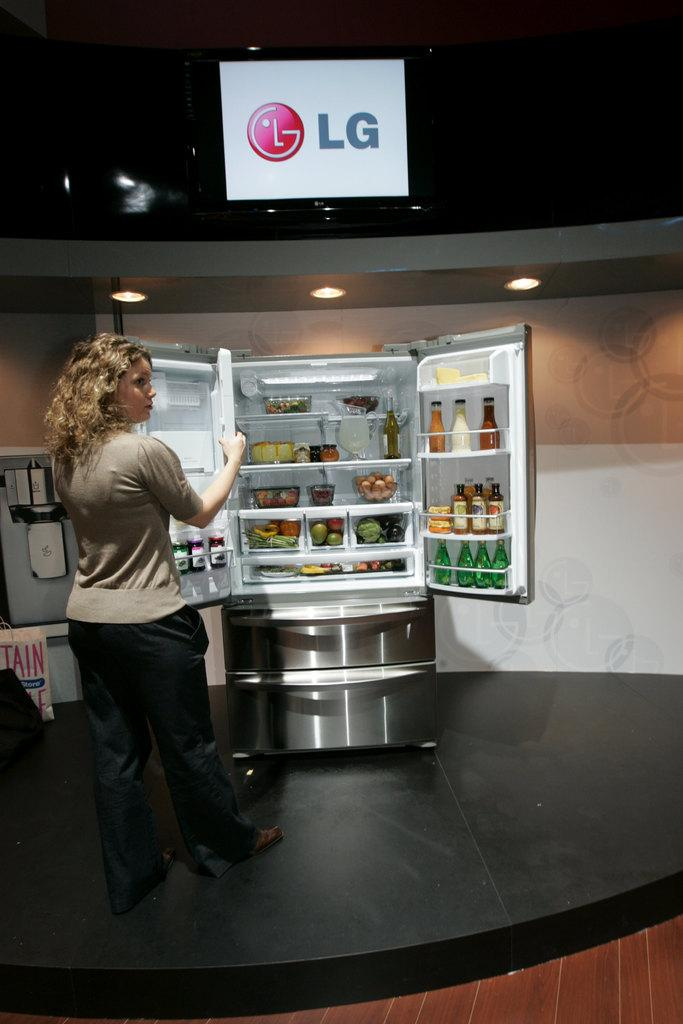<image>
Write a terse but informative summary of the picture. A showroom floor with an LG refrigerator on display. 